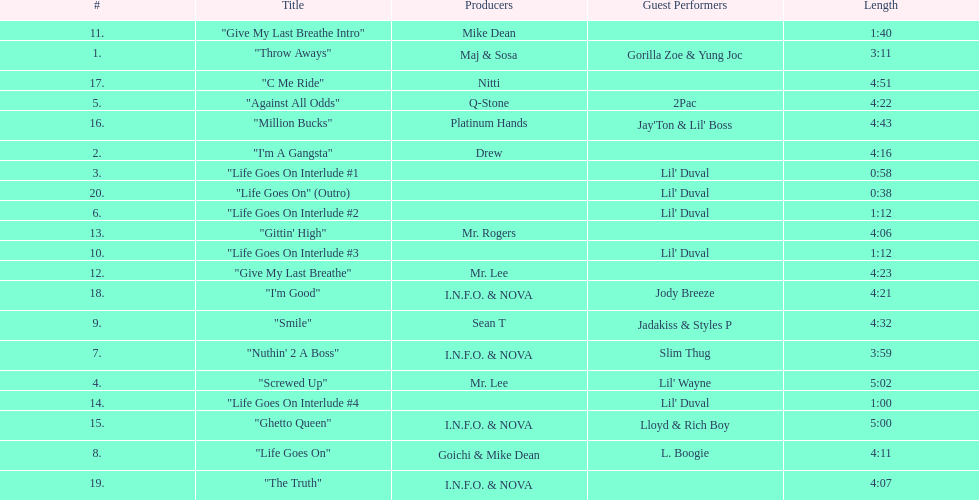Which producers produced the majority of songs on this record? I.N.F.O. & NOVA. 